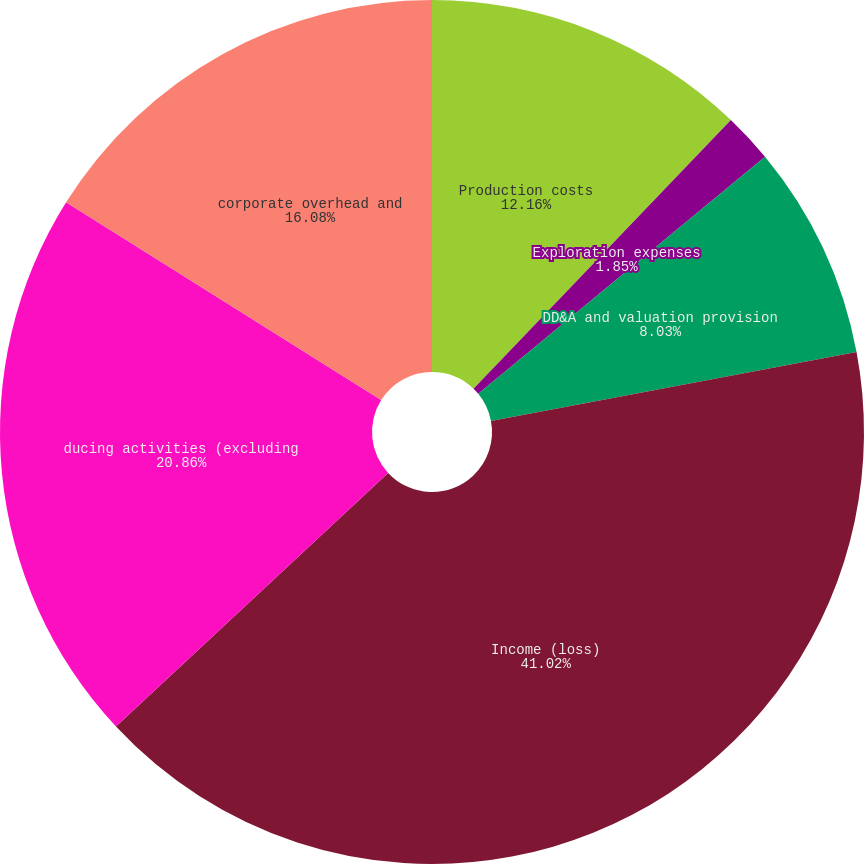Convert chart. <chart><loc_0><loc_0><loc_500><loc_500><pie_chart><fcel>Production costs<fcel>Exploration expenses<fcel>DD&A and valuation provision<fcel>Income (loss)<fcel>ducing activities (excluding<fcel>corporate overhead and<nl><fcel>12.16%<fcel>1.85%<fcel>8.03%<fcel>41.02%<fcel>20.86%<fcel>16.08%<nl></chart> 